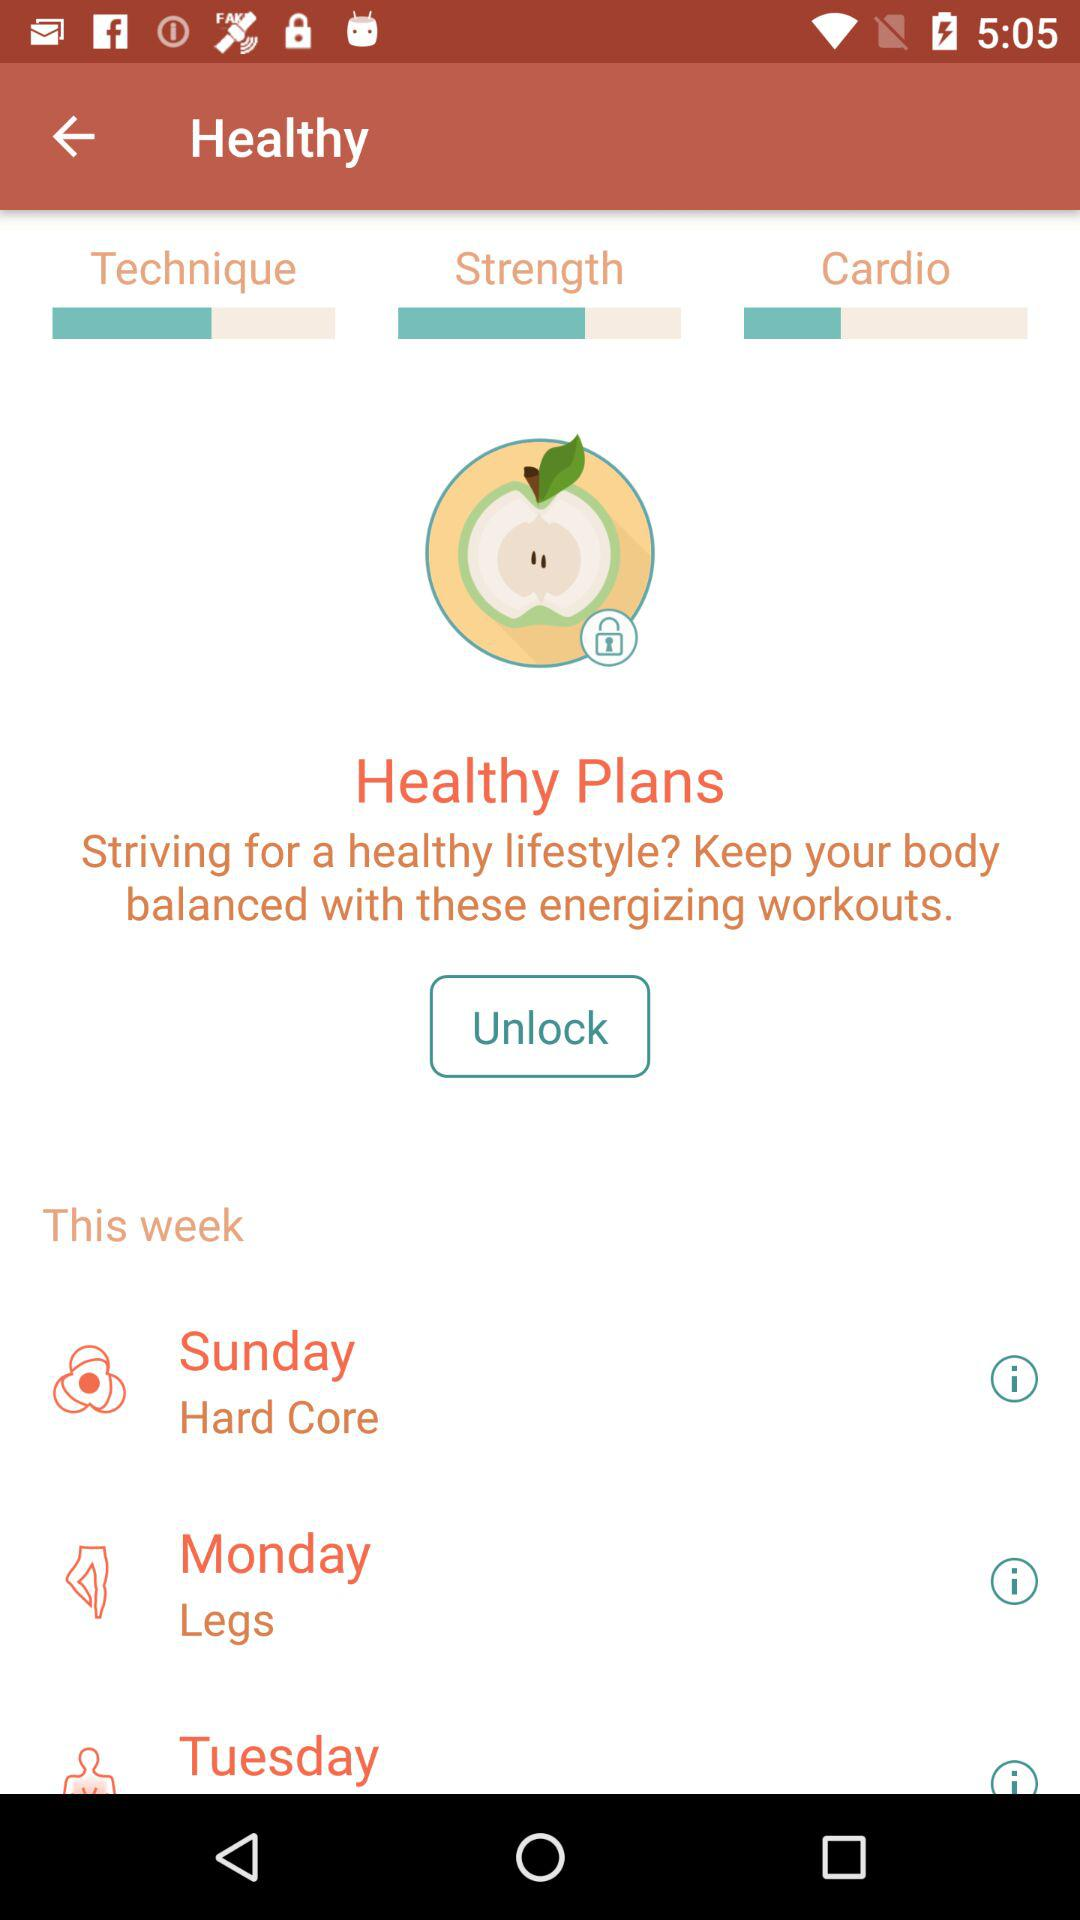What is the healthy plan for Sunday? The healthy plan for Sunday is "Hard Core". 